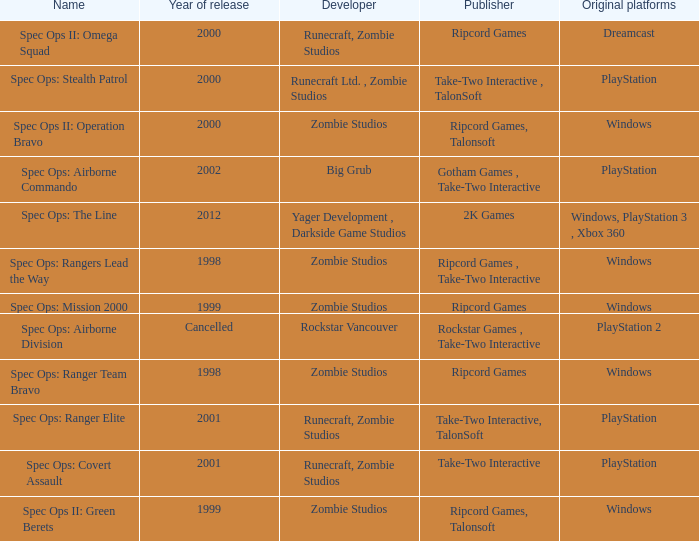Which publisher has release year of 2000 and an original dreamcast platform? Ripcord Games. 